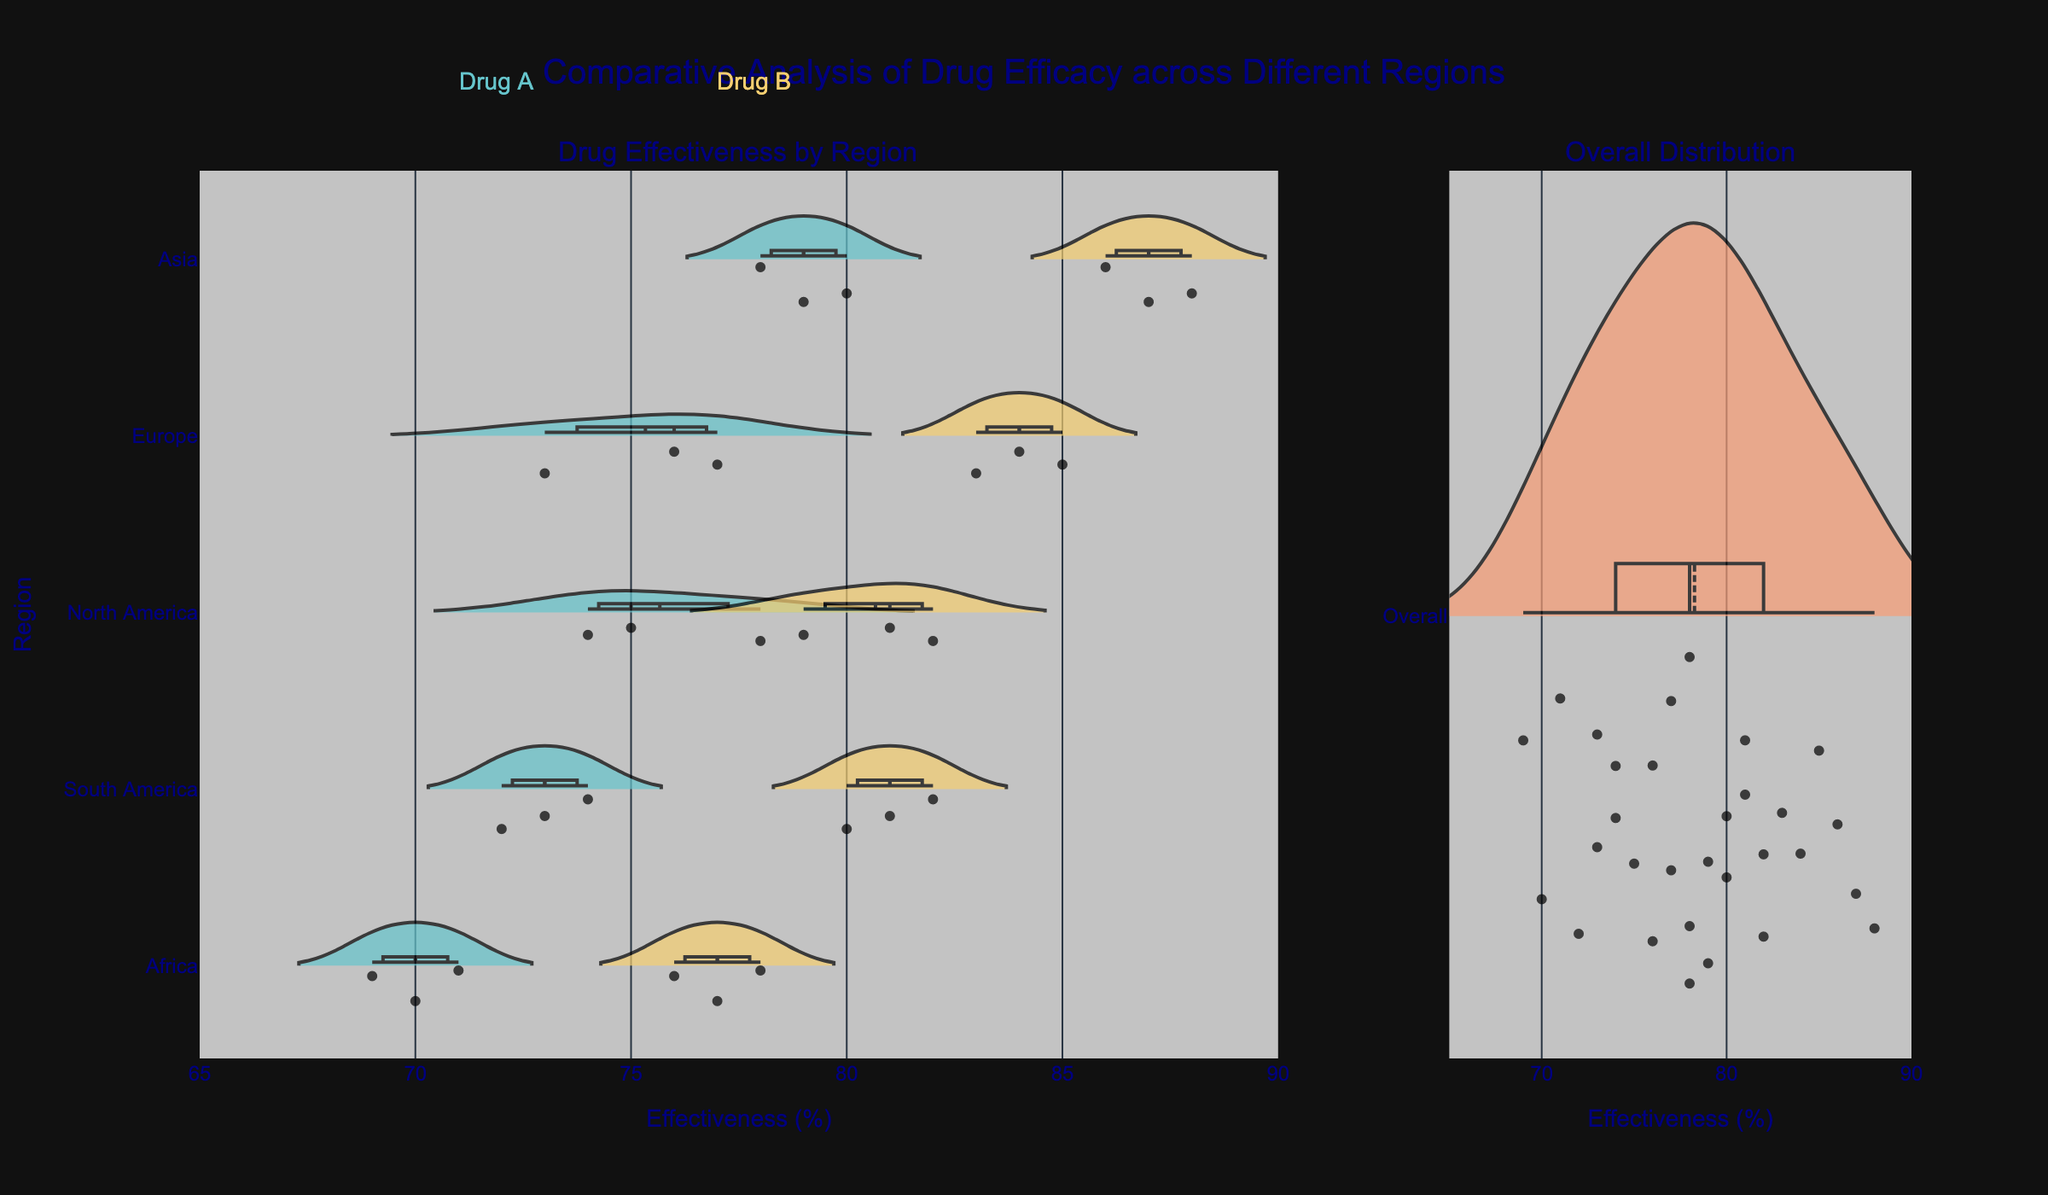How many regions are compared in the figure? The y-axis lists the regions, and by counting them visually in the figure, you will see: North America, Europe, Asia, South America, and Africa.
Answer: 5 Which drug shows higher effectiveness in Europe on average? To compare Drug A and Drug B in Europe, observe the central tendency (mean line) within their violins. Drug B's central tendency is higher than Drug A's.
Answer: Drug B What is the range of effectiveness for Drug A in South America? Look at the ends of the Drug A violin in South America. The minimum effectiveness is at 72 and the maximum effectiveness is at 74.
Answer: 72 to 74 Which region shows the lowest effectiveness for Drug B? Compare the bottom of the Drug B violins across all regions. Africa's Drug B violin has the lowest point at 76.
Answer: Africa Which region has the most variation in Drug B's effectiveness? To determine variation, observe the width and spread of each Drug B violin. Asia's Drug B violin is the widest and most spread out, indicating the most variation.
Answer: Asia How does the average effectiveness of Drug A in North America compare to the average effectiveness of Drug A in Asia? Compare the mean lines within the Drug A violins of North America and Asia. Drug A in Asia has a higher mean effectiveness than in North America.
Answer: Asia has higher average effectiveness What's the overall average effectiveness of all drugs across all regions? Look at the overall distribution violin plot on the right. The mean line indicates the average effectiveness which is between 75 and 80.
Answer: Between 75 and 80 Which drug has the higher maximum effectiveness in the entire dataset? Observe the highest points within the drug violins. Drug B shows a slightly higher maximum point of around 88 compared to Drug A's ~80.
Answer: Drug B Which region does Drug A perform the best in? Compare the uppermost points of Drug A violins across all regions. Asia's Drug A violin reaches the highest point at 80.
Answer: Asia 